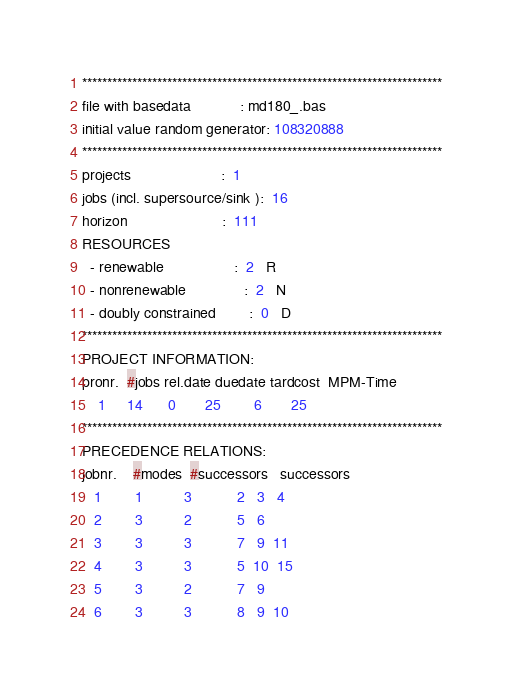Convert code to text. <code><loc_0><loc_0><loc_500><loc_500><_ObjectiveC_>************************************************************************
file with basedata            : md180_.bas
initial value random generator: 108320888
************************************************************************
projects                      :  1
jobs (incl. supersource/sink ):  16
horizon                       :  111
RESOURCES
  - renewable                 :  2   R
  - nonrenewable              :  2   N
  - doubly constrained        :  0   D
************************************************************************
PROJECT INFORMATION:
pronr.  #jobs rel.date duedate tardcost  MPM-Time
    1     14      0       25        6       25
************************************************************************
PRECEDENCE RELATIONS:
jobnr.    #modes  #successors   successors
   1        1          3           2   3   4
   2        3          2           5   6
   3        3          3           7   9  11
   4        3          3           5  10  15
   5        3          2           7   9
   6        3          3           8   9  10</code> 